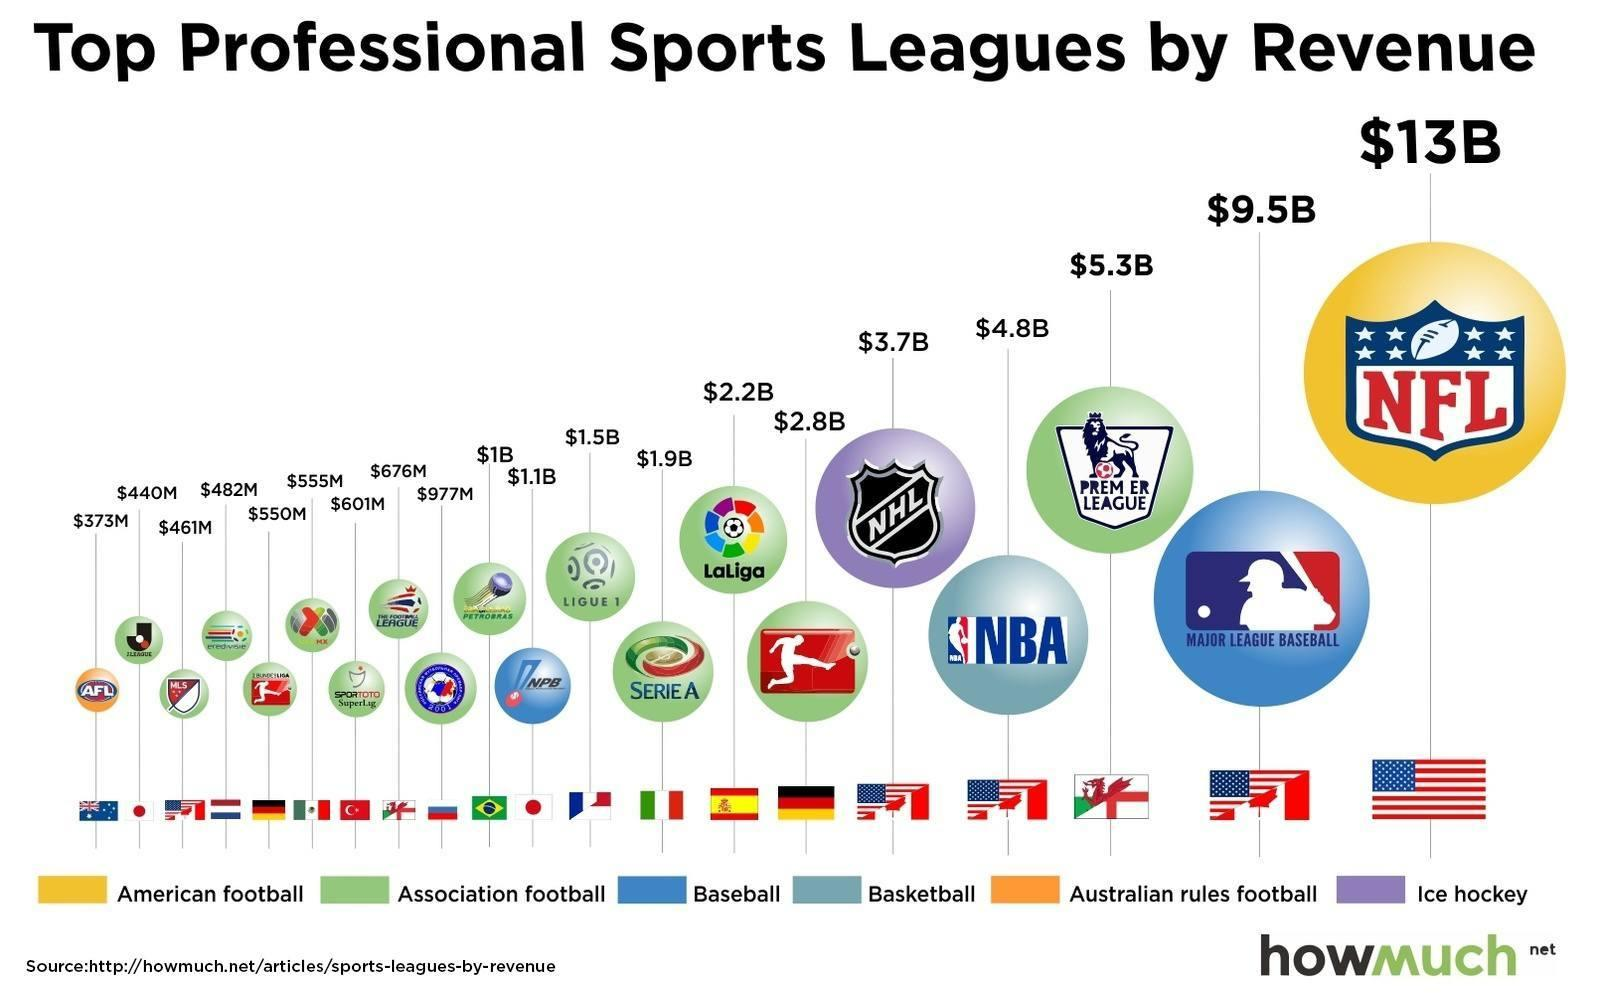Highlight a few significant elements in this photo. Major League Baseball is the highest revenue-generating professional baseball league in the United States. The National Football League (NFL) has generated the highest revenue among all professional sports leagues. The country whose football league is the NFL is the United States. The National Hockey League (NHL) is the professional ice hockey league in North America. LaLiga, the top-tier football league in Spain, is the country's premier football league. 